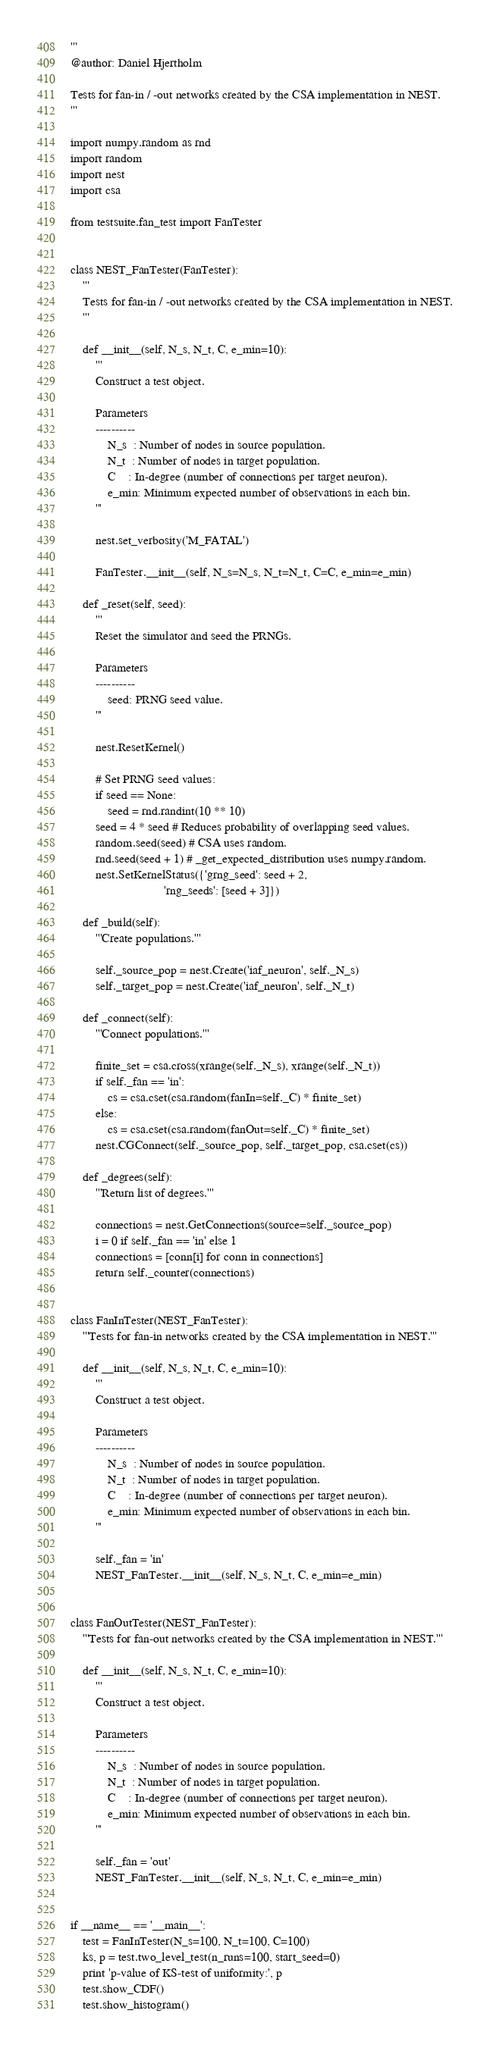Convert code to text. <code><loc_0><loc_0><loc_500><loc_500><_Python_>'''
@author: Daniel Hjertholm

Tests for fan-in / -out networks created by the CSA implementation in NEST.
'''

import numpy.random as rnd
import random
import nest
import csa

from testsuite.fan_test import FanTester


class NEST_FanTester(FanTester):
    '''
    Tests for fan-in / -out networks created by the CSA implementation in NEST.
    '''

    def __init__(self, N_s, N_t, C, e_min=10):
        '''
        Construct a test object.

        Parameters
        ----------
            N_s  : Number of nodes in source population.
            N_t  : Number of nodes in target population.
            C    : In-degree (number of connections per target neuron).
            e_min: Minimum expected number of observations in each bin.
        '''

        nest.set_verbosity('M_FATAL')

        FanTester.__init__(self, N_s=N_s, N_t=N_t, C=C, e_min=e_min)

    def _reset(self, seed):
        '''
        Reset the simulator and seed the PRNGs.

        Parameters
        ----------
            seed: PRNG seed value.
        '''

        nest.ResetKernel()

        # Set PRNG seed values:
        if seed == None:
            seed = rnd.randint(10 ** 10)
        seed = 4 * seed # Reduces probability of overlapping seed values.
        random.seed(seed) # CSA uses random.
        rnd.seed(seed + 1) # _get_expected_distribution uses numpy.random.
        nest.SetKernelStatus({'grng_seed': seed + 2,
                              'rng_seeds': [seed + 3]})

    def _build(self):
        '''Create populations.'''

        self._source_pop = nest.Create('iaf_neuron', self._N_s)
        self._target_pop = nest.Create('iaf_neuron', self._N_t)

    def _connect(self):
        '''Connect populations.'''

        finite_set = csa.cross(xrange(self._N_s), xrange(self._N_t))
        if self._fan == 'in':
            cs = csa.cset(csa.random(fanIn=self._C) * finite_set)
        else:
            cs = csa.cset(csa.random(fanOut=self._C) * finite_set)
        nest.CGConnect(self._source_pop, self._target_pop, csa.cset(cs))

    def _degrees(self):
        '''Return list of degrees.'''

        connections = nest.GetConnections(source=self._source_pop)
        i = 0 if self._fan == 'in' else 1
        connections = [conn[i] for conn in connections]
        return self._counter(connections)


class FanInTester(NEST_FanTester):
    '''Tests for fan-in networks created by the CSA implementation in NEST.'''

    def __init__(self, N_s, N_t, C, e_min=10):
        '''
        Construct a test object.

        Parameters
        ----------
            N_s  : Number of nodes in source population.
            N_t  : Number of nodes in target population.
            C    : In-degree (number of connections per target neuron).
            e_min: Minimum expected number of observations in each bin.
        '''

        self._fan = 'in'
        NEST_FanTester.__init__(self, N_s, N_t, C, e_min=e_min)


class FanOutTester(NEST_FanTester):
    '''Tests for fan-out networks created by the CSA implementation in NEST.'''

    def __init__(self, N_s, N_t, C, e_min=10):
        '''
        Construct a test object.

        Parameters
        ----------
            N_s  : Number of nodes in source population.
            N_t  : Number of nodes in target population.
            C    : In-degree (number of connections per target neuron).
            e_min: Minimum expected number of observations in each bin.
        '''

        self._fan = 'out'
        NEST_FanTester.__init__(self, N_s, N_t, C, e_min=e_min)


if __name__ == '__main__':
    test = FanInTester(N_s=100, N_t=100, C=100)
    ks, p = test.two_level_test(n_runs=100, start_seed=0)
    print 'p-value of KS-test of uniformity:', p
    test.show_CDF()
    test.show_histogram()
</code> 